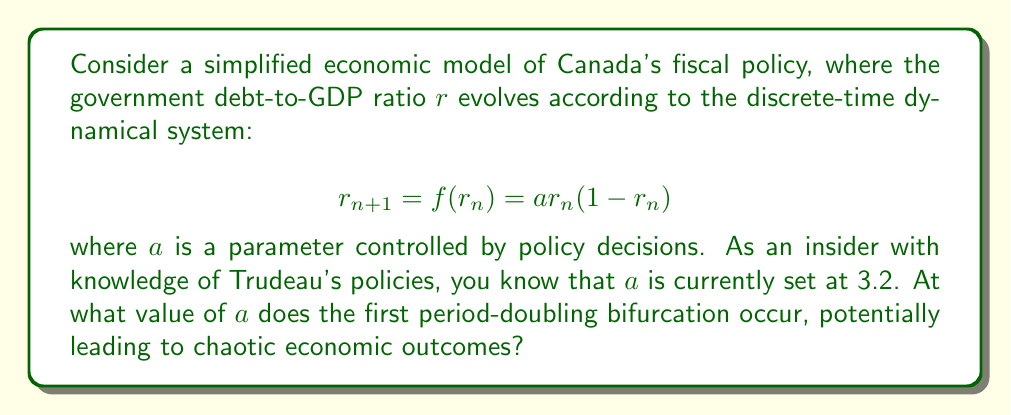Can you answer this question? To find the first period-doubling bifurcation point, we need to follow these steps:

1) First, we find the fixed points of the system by solving:
   $$r^* = f(r^*) = ar^*(1-r^*)$$
   
   This gives us two fixed points: $r^*_1 = 0$ and $r^*_2 = 1 - \frac{1}{a}$

2) We focus on the non-zero fixed point $r^*_2 = 1 - \frac{1}{a}$, as this is the one that will undergo bifurcation.

3) To determine stability, we calculate the derivative of $f(r)$:
   $$f'(r) = a(1-2r)$$

4) Evaluate this at the fixed point:
   $$f'(r^*_2) = a(1-2(1-\frac{1}{a})) = a(1-2+\frac{2}{a}) = 2-a$$

5) The fixed point loses stability when $|f'(r^*_2)| = 1$. In this case, we're looking for the negative case where $f'(r^*_2) = -1$:
   $$2-a = -1$$
   $$a = 3$$

6) Therefore, the first period-doubling bifurcation occurs at $a = 3$.

This bifurcation point represents a critical threshold in the economic policy. When $a$ exceeds 3, the system transitions from a stable equilibrium to a 2-period cycle, marking the beginning of more complex dynamics that could eventually lead to chaos.
Answer: $a = 3$ 